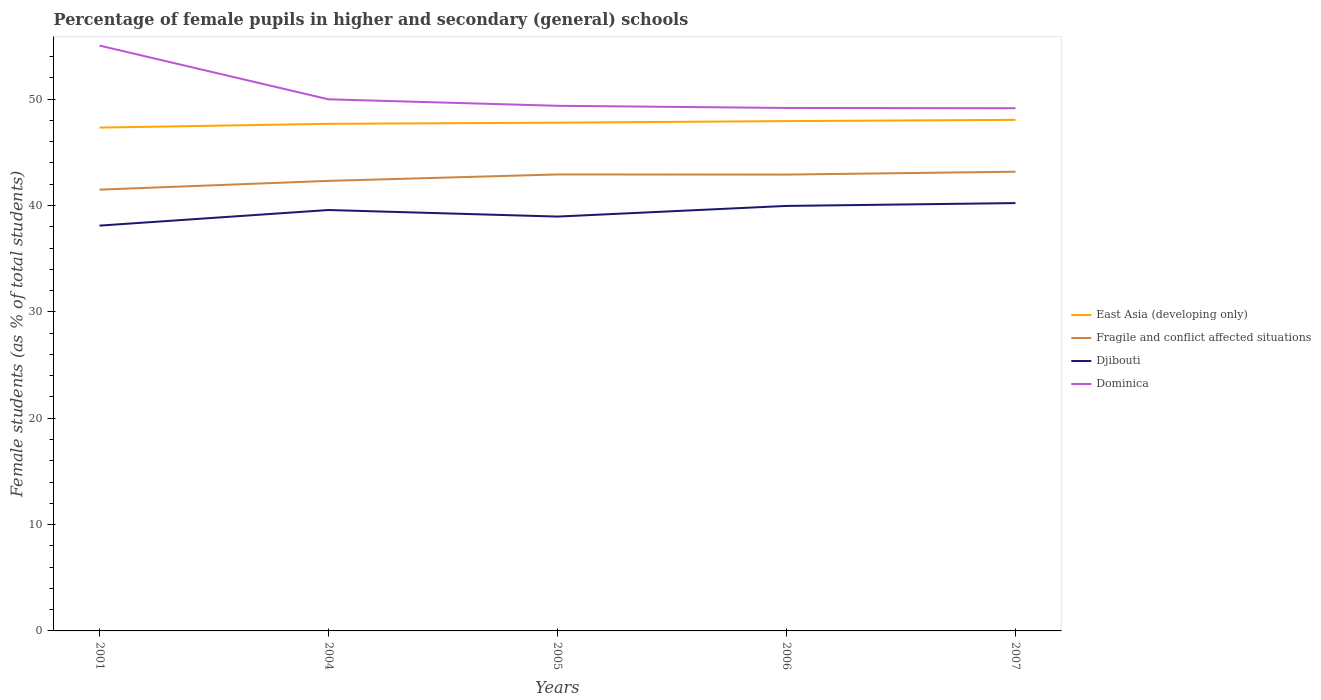Is the number of lines equal to the number of legend labels?
Your answer should be compact. Yes. Across all years, what is the maximum percentage of female pupils in higher and secondary schools in Fragile and conflict affected situations?
Give a very brief answer. 41.49. In which year was the percentage of female pupils in higher and secondary schools in Dominica maximum?
Ensure brevity in your answer.  2007. What is the total percentage of female pupils in higher and secondary schools in East Asia (developing only) in the graph?
Give a very brief answer. -0.61. What is the difference between the highest and the second highest percentage of female pupils in higher and secondary schools in Fragile and conflict affected situations?
Ensure brevity in your answer.  1.69. What is the difference between the highest and the lowest percentage of female pupils in higher and secondary schools in Djibouti?
Your response must be concise. 3. Is the percentage of female pupils in higher and secondary schools in Fragile and conflict affected situations strictly greater than the percentage of female pupils in higher and secondary schools in Djibouti over the years?
Keep it short and to the point. No. How many lines are there?
Keep it short and to the point. 4. Does the graph contain any zero values?
Provide a succinct answer. No. Does the graph contain grids?
Give a very brief answer. No. Where does the legend appear in the graph?
Offer a very short reply. Center right. How many legend labels are there?
Give a very brief answer. 4. What is the title of the graph?
Provide a succinct answer. Percentage of female pupils in higher and secondary (general) schools. What is the label or title of the Y-axis?
Offer a terse response. Female students (as % of total students). What is the Female students (as % of total students) of East Asia (developing only) in 2001?
Offer a very short reply. 47.33. What is the Female students (as % of total students) in Fragile and conflict affected situations in 2001?
Provide a succinct answer. 41.49. What is the Female students (as % of total students) of Djibouti in 2001?
Offer a very short reply. 38.11. What is the Female students (as % of total students) of Dominica in 2001?
Your answer should be compact. 55.04. What is the Female students (as % of total students) of East Asia (developing only) in 2004?
Provide a succinct answer. 47.68. What is the Female students (as % of total students) in Fragile and conflict affected situations in 2004?
Give a very brief answer. 42.32. What is the Female students (as % of total students) in Djibouti in 2004?
Provide a succinct answer. 39.58. What is the Female students (as % of total students) of Dominica in 2004?
Your answer should be very brief. 49.99. What is the Female students (as % of total students) of East Asia (developing only) in 2005?
Give a very brief answer. 47.79. What is the Female students (as % of total students) in Fragile and conflict affected situations in 2005?
Your answer should be very brief. 42.92. What is the Female students (as % of total students) of Djibouti in 2005?
Give a very brief answer. 38.96. What is the Female students (as % of total students) of Dominica in 2005?
Your response must be concise. 49.38. What is the Female students (as % of total students) of East Asia (developing only) in 2006?
Provide a short and direct response. 47.94. What is the Female students (as % of total students) in Fragile and conflict affected situations in 2006?
Make the answer very short. 42.91. What is the Female students (as % of total students) in Djibouti in 2006?
Provide a short and direct response. 39.96. What is the Female students (as % of total students) in Dominica in 2006?
Provide a succinct answer. 49.17. What is the Female students (as % of total students) of East Asia (developing only) in 2007?
Offer a terse response. 48.05. What is the Female students (as % of total students) of Fragile and conflict affected situations in 2007?
Keep it short and to the point. 43.18. What is the Female students (as % of total students) of Djibouti in 2007?
Your answer should be very brief. 40.23. What is the Female students (as % of total students) of Dominica in 2007?
Provide a succinct answer. 49.15. Across all years, what is the maximum Female students (as % of total students) in East Asia (developing only)?
Make the answer very short. 48.05. Across all years, what is the maximum Female students (as % of total students) of Fragile and conflict affected situations?
Your answer should be compact. 43.18. Across all years, what is the maximum Female students (as % of total students) in Djibouti?
Provide a succinct answer. 40.23. Across all years, what is the maximum Female students (as % of total students) of Dominica?
Keep it short and to the point. 55.04. Across all years, what is the minimum Female students (as % of total students) in East Asia (developing only)?
Ensure brevity in your answer.  47.33. Across all years, what is the minimum Female students (as % of total students) in Fragile and conflict affected situations?
Keep it short and to the point. 41.49. Across all years, what is the minimum Female students (as % of total students) in Djibouti?
Provide a short and direct response. 38.11. Across all years, what is the minimum Female students (as % of total students) in Dominica?
Provide a short and direct response. 49.15. What is the total Female students (as % of total students) in East Asia (developing only) in the graph?
Your answer should be very brief. 238.79. What is the total Female students (as % of total students) in Fragile and conflict affected situations in the graph?
Provide a short and direct response. 212.82. What is the total Female students (as % of total students) of Djibouti in the graph?
Give a very brief answer. 196.84. What is the total Female students (as % of total students) in Dominica in the graph?
Provide a succinct answer. 252.72. What is the difference between the Female students (as % of total students) in East Asia (developing only) in 2001 and that in 2004?
Your answer should be compact. -0.36. What is the difference between the Female students (as % of total students) of Fragile and conflict affected situations in 2001 and that in 2004?
Offer a terse response. -0.82. What is the difference between the Female students (as % of total students) in Djibouti in 2001 and that in 2004?
Provide a short and direct response. -1.47. What is the difference between the Female students (as % of total students) in Dominica in 2001 and that in 2004?
Your answer should be compact. 5.05. What is the difference between the Female students (as % of total students) in East Asia (developing only) in 2001 and that in 2005?
Provide a succinct answer. -0.47. What is the difference between the Female students (as % of total students) in Fragile and conflict affected situations in 2001 and that in 2005?
Give a very brief answer. -1.43. What is the difference between the Female students (as % of total students) of Djibouti in 2001 and that in 2005?
Your answer should be compact. -0.85. What is the difference between the Female students (as % of total students) of Dominica in 2001 and that in 2005?
Keep it short and to the point. 5.66. What is the difference between the Female students (as % of total students) in East Asia (developing only) in 2001 and that in 2006?
Offer a very short reply. -0.61. What is the difference between the Female students (as % of total students) of Fragile and conflict affected situations in 2001 and that in 2006?
Your answer should be very brief. -1.42. What is the difference between the Female students (as % of total students) in Djibouti in 2001 and that in 2006?
Keep it short and to the point. -1.85. What is the difference between the Female students (as % of total students) in Dominica in 2001 and that in 2006?
Offer a very short reply. 5.86. What is the difference between the Female students (as % of total students) in East Asia (developing only) in 2001 and that in 2007?
Keep it short and to the point. -0.73. What is the difference between the Female students (as % of total students) of Fragile and conflict affected situations in 2001 and that in 2007?
Provide a short and direct response. -1.69. What is the difference between the Female students (as % of total students) of Djibouti in 2001 and that in 2007?
Your answer should be compact. -2.12. What is the difference between the Female students (as % of total students) of Dominica in 2001 and that in 2007?
Give a very brief answer. 5.89. What is the difference between the Female students (as % of total students) in East Asia (developing only) in 2004 and that in 2005?
Provide a short and direct response. -0.11. What is the difference between the Female students (as % of total students) in Fragile and conflict affected situations in 2004 and that in 2005?
Offer a very short reply. -0.6. What is the difference between the Female students (as % of total students) in Djibouti in 2004 and that in 2005?
Your answer should be compact. 0.62. What is the difference between the Female students (as % of total students) in Dominica in 2004 and that in 2005?
Make the answer very short. 0.61. What is the difference between the Female students (as % of total students) of East Asia (developing only) in 2004 and that in 2006?
Offer a very short reply. -0.26. What is the difference between the Female students (as % of total students) in Fragile and conflict affected situations in 2004 and that in 2006?
Your response must be concise. -0.59. What is the difference between the Female students (as % of total students) of Djibouti in 2004 and that in 2006?
Give a very brief answer. -0.38. What is the difference between the Female students (as % of total students) of Dominica in 2004 and that in 2006?
Keep it short and to the point. 0.81. What is the difference between the Female students (as % of total students) in East Asia (developing only) in 2004 and that in 2007?
Make the answer very short. -0.37. What is the difference between the Female students (as % of total students) in Fragile and conflict affected situations in 2004 and that in 2007?
Provide a short and direct response. -0.86. What is the difference between the Female students (as % of total students) in Djibouti in 2004 and that in 2007?
Your answer should be compact. -0.65. What is the difference between the Female students (as % of total students) in Dominica in 2004 and that in 2007?
Your response must be concise. 0.84. What is the difference between the Female students (as % of total students) in East Asia (developing only) in 2005 and that in 2006?
Give a very brief answer. -0.15. What is the difference between the Female students (as % of total students) of Fragile and conflict affected situations in 2005 and that in 2006?
Give a very brief answer. 0.01. What is the difference between the Female students (as % of total students) of Djibouti in 2005 and that in 2006?
Offer a terse response. -1. What is the difference between the Female students (as % of total students) in Dominica in 2005 and that in 2006?
Your answer should be compact. 0.2. What is the difference between the Female students (as % of total students) in East Asia (developing only) in 2005 and that in 2007?
Provide a short and direct response. -0.26. What is the difference between the Female students (as % of total students) in Fragile and conflict affected situations in 2005 and that in 2007?
Provide a succinct answer. -0.26. What is the difference between the Female students (as % of total students) in Djibouti in 2005 and that in 2007?
Provide a short and direct response. -1.27. What is the difference between the Female students (as % of total students) of Dominica in 2005 and that in 2007?
Make the answer very short. 0.23. What is the difference between the Female students (as % of total students) of East Asia (developing only) in 2006 and that in 2007?
Provide a short and direct response. -0.12. What is the difference between the Female students (as % of total students) in Fragile and conflict affected situations in 2006 and that in 2007?
Provide a short and direct response. -0.27. What is the difference between the Female students (as % of total students) of Djibouti in 2006 and that in 2007?
Your response must be concise. -0.27. What is the difference between the Female students (as % of total students) of Dominica in 2006 and that in 2007?
Your response must be concise. 0.03. What is the difference between the Female students (as % of total students) of East Asia (developing only) in 2001 and the Female students (as % of total students) of Fragile and conflict affected situations in 2004?
Offer a very short reply. 5.01. What is the difference between the Female students (as % of total students) in East Asia (developing only) in 2001 and the Female students (as % of total students) in Djibouti in 2004?
Offer a terse response. 7.75. What is the difference between the Female students (as % of total students) of East Asia (developing only) in 2001 and the Female students (as % of total students) of Dominica in 2004?
Your response must be concise. -2.66. What is the difference between the Female students (as % of total students) of Fragile and conflict affected situations in 2001 and the Female students (as % of total students) of Djibouti in 2004?
Your answer should be compact. 1.91. What is the difference between the Female students (as % of total students) of Fragile and conflict affected situations in 2001 and the Female students (as % of total students) of Dominica in 2004?
Your answer should be very brief. -8.49. What is the difference between the Female students (as % of total students) in Djibouti in 2001 and the Female students (as % of total students) in Dominica in 2004?
Provide a succinct answer. -11.88. What is the difference between the Female students (as % of total students) of East Asia (developing only) in 2001 and the Female students (as % of total students) of Fragile and conflict affected situations in 2005?
Offer a terse response. 4.4. What is the difference between the Female students (as % of total students) in East Asia (developing only) in 2001 and the Female students (as % of total students) in Djibouti in 2005?
Your response must be concise. 8.37. What is the difference between the Female students (as % of total students) of East Asia (developing only) in 2001 and the Female students (as % of total students) of Dominica in 2005?
Offer a very short reply. -2.05. What is the difference between the Female students (as % of total students) of Fragile and conflict affected situations in 2001 and the Female students (as % of total students) of Djibouti in 2005?
Provide a short and direct response. 2.53. What is the difference between the Female students (as % of total students) of Fragile and conflict affected situations in 2001 and the Female students (as % of total students) of Dominica in 2005?
Your answer should be very brief. -7.88. What is the difference between the Female students (as % of total students) of Djibouti in 2001 and the Female students (as % of total students) of Dominica in 2005?
Your response must be concise. -11.27. What is the difference between the Female students (as % of total students) in East Asia (developing only) in 2001 and the Female students (as % of total students) in Fragile and conflict affected situations in 2006?
Provide a short and direct response. 4.42. What is the difference between the Female students (as % of total students) in East Asia (developing only) in 2001 and the Female students (as % of total students) in Djibouti in 2006?
Your response must be concise. 7.36. What is the difference between the Female students (as % of total students) of East Asia (developing only) in 2001 and the Female students (as % of total students) of Dominica in 2006?
Your answer should be very brief. -1.85. What is the difference between the Female students (as % of total students) of Fragile and conflict affected situations in 2001 and the Female students (as % of total students) of Djibouti in 2006?
Keep it short and to the point. 1.53. What is the difference between the Female students (as % of total students) of Fragile and conflict affected situations in 2001 and the Female students (as % of total students) of Dominica in 2006?
Your answer should be compact. -7.68. What is the difference between the Female students (as % of total students) in Djibouti in 2001 and the Female students (as % of total students) in Dominica in 2006?
Your response must be concise. -11.06. What is the difference between the Female students (as % of total students) in East Asia (developing only) in 2001 and the Female students (as % of total students) in Fragile and conflict affected situations in 2007?
Your answer should be very brief. 4.15. What is the difference between the Female students (as % of total students) of East Asia (developing only) in 2001 and the Female students (as % of total students) of Djibouti in 2007?
Make the answer very short. 7.1. What is the difference between the Female students (as % of total students) in East Asia (developing only) in 2001 and the Female students (as % of total students) in Dominica in 2007?
Keep it short and to the point. -1.82. What is the difference between the Female students (as % of total students) in Fragile and conflict affected situations in 2001 and the Female students (as % of total students) in Djibouti in 2007?
Your answer should be very brief. 1.26. What is the difference between the Female students (as % of total students) of Fragile and conflict affected situations in 2001 and the Female students (as % of total students) of Dominica in 2007?
Offer a very short reply. -7.66. What is the difference between the Female students (as % of total students) of Djibouti in 2001 and the Female students (as % of total students) of Dominica in 2007?
Make the answer very short. -11.04. What is the difference between the Female students (as % of total students) in East Asia (developing only) in 2004 and the Female students (as % of total students) in Fragile and conflict affected situations in 2005?
Make the answer very short. 4.76. What is the difference between the Female students (as % of total students) of East Asia (developing only) in 2004 and the Female students (as % of total students) of Djibouti in 2005?
Give a very brief answer. 8.72. What is the difference between the Female students (as % of total students) of East Asia (developing only) in 2004 and the Female students (as % of total students) of Dominica in 2005?
Your answer should be compact. -1.69. What is the difference between the Female students (as % of total students) of Fragile and conflict affected situations in 2004 and the Female students (as % of total students) of Djibouti in 2005?
Offer a terse response. 3.36. What is the difference between the Female students (as % of total students) of Fragile and conflict affected situations in 2004 and the Female students (as % of total students) of Dominica in 2005?
Make the answer very short. -7.06. What is the difference between the Female students (as % of total students) in Djibouti in 2004 and the Female students (as % of total students) in Dominica in 2005?
Your response must be concise. -9.8. What is the difference between the Female students (as % of total students) in East Asia (developing only) in 2004 and the Female students (as % of total students) in Fragile and conflict affected situations in 2006?
Your response must be concise. 4.77. What is the difference between the Female students (as % of total students) of East Asia (developing only) in 2004 and the Female students (as % of total students) of Djibouti in 2006?
Your answer should be compact. 7.72. What is the difference between the Female students (as % of total students) of East Asia (developing only) in 2004 and the Female students (as % of total students) of Dominica in 2006?
Your answer should be compact. -1.49. What is the difference between the Female students (as % of total students) of Fragile and conflict affected situations in 2004 and the Female students (as % of total students) of Djibouti in 2006?
Ensure brevity in your answer.  2.35. What is the difference between the Female students (as % of total students) in Fragile and conflict affected situations in 2004 and the Female students (as % of total students) in Dominica in 2006?
Provide a succinct answer. -6.86. What is the difference between the Female students (as % of total students) of Djibouti in 2004 and the Female students (as % of total students) of Dominica in 2006?
Provide a succinct answer. -9.6. What is the difference between the Female students (as % of total students) in East Asia (developing only) in 2004 and the Female students (as % of total students) in Fragile and conflict affected situations in 2007?
Give a very brief answer. 4.5. What is the difference between the Female students (as % of total students) of East Asia (developing only) in 2004 and the Female students (as % of total students) of Djibouti in 2007?
Your answer should be very brief. 7.45. What is the difference between the Female students (as % of total students) in East Asia (developing only) in 2004 and the Female students (as % of total students) in Dominica in 2007?
Ensure brevity in your answer.  -1.46. What is the difference between the Female students (as % of total students) in Fragile and conflict affected situations in 2004 and the Female students (as % of total students) in Djibouti in 2007?
Offer a very short reply. 2.09. What is the difference between the Female students (as % of total students) in Fragile and conflict affected situations in 2004 and the Female students (as % of total students) in Dominica in 2007?
Offer a terse response. -6.83. What is the difference between the Female students (as % of total students) in Djibouti in 2004 and the Female students (as % of total students) in Dominica in 2007?
Provide a succinct answer. -9.57. What is the difference between the Female students (as % of total students) of East Asia (developing only) in 2005 and the Female students (as % of total students) of Fragile and conflict affected situations in 2006?
Keep it short and to the point. 4.88. What is the difference between the Female students (as % of total students) in East Asia (developing only) in 2005 and the Female students (as % of total students) in Djibouti in 2006?
Your answer should be very brief. 7.83. What is the difference between the Female students (as % of total students) in East Asia (developing only) in 2005 and the Female students (as % of total students) in Dominica in 2006?
Give a very brief answer. -1.38. What is the difference between the Female students (as % of total students) in Fragile and conflict affected situations in 2005 and the Female students (as % of total students) in Djibouti in 2006?
Provide a short and direct response. 2.96. What is the difference between the Female students (as % of total students) in Fragile and conflict affected situations in 2005 and the Female students (as % of total students) in Dominica in 2006?
Give a very brief answer. -6.25. What is the difference between the Female students (as % of total students) of Djibouti in 2005 and the Female students (as % of total students) of Dominica in 2006?
Offer a very short reply. -10.21. What is the difference between the Female students (as % of total students) in East Asia (developing only) in 2005 and the Female students (as % of total students) in Fragile and conflict affected situations in 2007?
Make the answer very short. 4.61. What is the difference between the Female students (as % of total students) in East Asia (developing only) in 2005 and the Female students (as % of total students) in Djibouti in 2007?
Provide a succinct answer. 7.56. What is the difference between the Female students (as % of total students) in East Asia (developing only) in 2005 and the Female students (as % of total students) in Dominica in 2007?
Your answer should be compact. -1.36. What is the difference between the Female students (as % of total students) in Fragile and conflict affected situations in 2005 and the Female students (as % of total students) in Djibouti in 2007?
Provide a succinct answer. 2.69. What is the difference between the Female students (as % of total students) of Fragile and conflict affected situations in 2005 and the Female students (as % of total students) of Dominica in 2007?
Your answer should be very brief. -6.23. What is the difference between the Female students (as % of total students) of Djibouti in 2005 and the Female students (as % of total students) of Dominica in 2007?
Your answer should be compact. -10.19. What is the difference between the Female students (as % of total students) in East Asia (developing only) in 2006 and the Female students (as % of total students) in Fragile and conflict affected situations in 2007?
Your answer should be compact. 4.76. What is the difference between the Female students (as % of total students) of East Asia (developing only) in 2006 and the Female students (as % of total students) of Djibouti in 2007?
Give a very brief answer. 7.71. What is the difference between the Female students (as % of total students) of East Asia (developing only) in 2006 and the Female students (as % of total students) of Dominica in 2007?
Give a very brief answer. -1.21. What is the difference between the Female students (as % of total students) in Fragile and conflict affected situations in 2006 and the Female students (as % of total students) in Djibouti in 2007?
Give a very brief answer. 2.68. What is the difference between the Female students (as % of total students) in Fragile and conflict affected situations in 2006 and the Female students (as % of total students) in Dominica in 2007?
Offer a terse response. -6.24. What is the difference between the Female students (as % of total students) of Djibouti in 2006 and the Female students (as % of total students) of Dominica in 2007?
Provide a succinct answer. -9.18. What is the average Female students (as % of total students) of East Asia (developing only) per year?
Provide a short and direct response. 47.76. What is the average Female students (as % of total students) in Fragile and conflict affected situations per year?
Keep it short and to the point. 42.56. What is the average Female students (as % of total students) in Djibouti per year?
Provide a short and direct response. 39.37. What is the average Female students (as % of total students) of Dominica per year?
Provide a short and direct response. 50.54. In the year 2001, what is the difference between the Female students (as % of total students) of East Asia (developing only) and Female students (as % of total students) of Fragile and conflict affected situations?
Ensure brevity in your answer.  5.83. In the year 2001, what is the difference between the Female students (as % of total students) in East Asia (developing only) and Female students (as % of total students) in Djibouti?
Provide a succinct answer. 9.22. In the year 2001, what is the difference between the Female students (as % of total students) of East Asia (developing only) and Female students (as % of total students) of Dominica?
Offer a very short reply. -7.71. In the year 2001, what is the difference between the Female students (as % of total students) of Fragile and conflict affected situations and Female students (as % of total students) of Djibouti?
Your answer should be compact. 3.38. In the year 2001, what is the difference between the Female students (as % of total students) of Fragile and conflict affected situations and Female students (as % of total students) of Dominica?
Give a very brief answer. -13.55. In the year 2001, what is the difference between the Female students (as % of total students) of Djibouti and Female students (as % of total students) of Dominica?
Offer a very short reply. -16.93. In the year 2004, what is the difference between the Female students (as % of total students) in East Asia (developing only) and Female students (as % of total students) in Fragile and conflict affected situations?
Provide a succinct answer. 5.37. In the year 2004, what is the difference between the Female students (as % of total students) in East Asia (developing only) and Female students (as % of total students) in Djibouti?
Ensure brevity in your answer.  8.1. In the year 2004, what is the difference between the Female students (as % of total students) in East Asia (developing only) and Female students (as % of total students) in Dominica?
Offer a terse response. -2.3. In the year 2004, what is the difference between the Female students (as % of total students) of Fragile and conflict affected situations and Female students (as % of total students) of Djibouti?
Make the answer very short. 2.74. In the year 2004, what is the difference between the Female students (as % of total students) in Fragile and conflict affected situations and Female students (as % of total students) in Dominica?
Your response must be concise. -7.67. In the year 2004, what is the difference between the Female students (as % of total students) in Djibouti and Female students (as % of total students) in Dominica?
Offer a very short reply. -10.41. In the year 2005, what is the difference between the Female students (as % of total students) of East Asia (developing only) and Female students (as % of total students) of Fragile and conflict affected situations?
Your response must be concise. 4.87. In the year 2005, what is the difference between the Female students (as % of total students) of East Asia (developing only) and Female students (as % of total students) of Djibouti?
Provide a short and direct response. 8.83. In the year 2005, what is the difference between the Female students (as % of total students) of East Asia (developing only) and Female students (as % of total students) of Dominica?
Offer a very short reply. -1.59. In the year 2005, what is the difference between the Female students (as % of total students) of Fragile and conflict affected situations and Female students (as % of total students) of Djibouti?
Give a very brief answer. 3.96. In the year 2005, what is the difference between the Female students (as % of total students) of Fragile and conflict affected situations and Female students (as % of total students) of Dominica?
Offer a very short reply. -6.46. In the year 2005, what is the difference between the Female students (as % of total students) of Djibouti and Female students (as % of total students) of Dominica?
Offer a terse response. -10.42. In the year 2006, what is the difference between the Female students (as % of total students) in East Asia (developing only) and Female students (as % of total students) in Fragile and conflict affected situations?
Ensure brevity in your answer.  5.03. In the year 2006, what is the difference between the Female students (as % of total students) of East Asia (developing only) and Female students (as % of total students) of Djibouti?
Your answer should be very brief. 7.98. In the year 2006, what is the difference between the Female students (as % of total students) of East Asia (developing only) and Female students (as % of total students) of Dominica?
Make the answer very short. -1.24. In the year 2006, what is the difference between the Female students (as % of total students) of Fragile and conflict affected situations and Female students (as % of total students) of Djibouti?
Keep it short and to the point. 2.95. In the year 2006, what is the difference between the Female students (as % of total students) in Fragile and conflict affected situations and Female students (as % of total students) in Dominica?
Ensure brevity in your answer.  -6.26. In the year 2006, what is the difference between the Female students (as % of total students) in Djibouti and Female students (as % of total students) in Dominica?
Your response must be concise. -9.21. In the year 2007, what is the difference between the Female students (as % of total students) in East Asia (developing only) and Female students (as % of total students) in Fragile and conflict affected situations?
Provide a succinct answer. 4.88. In the year 2007, what is the difference between the Female students (as % of total students) in East Asia (developing only) and Female students (as % of total students) in Djibouti?
Your answer should be very brief. 7.83. In the year 2007, what is the difference between the Female students (as % of total students) in East Asia (developing only) and Female students (as % of total students) in Dominica?
Keep it short and to the point. -1.09. In the year 2007, what is the difference between the Female students (as % of total students) of Fragile and conflict affected situations and Female students (as % of total students) of Djibouti?
Provide a succinct answer. 2.95. In the year 2007, what is the difference between the Female students (as % of total students) in Fragile and conflict affected situations and Female students (as % of total students) in Dominica?
Provide a succinct answer. -5.97. In the year 2007, what is the difference between the Female students (as % of total students) of Djibouti and Female students (as % of total students) of Dominica?
Your response must be concise. -8.92. What is the ratio of the Female students (as % of total students) in Fragile and conflict affected situations in 2001 to that in 2004?
Ensure brevity in your answer.  0.98. What is the ratio of the Female students (as % of total students) in Djibouti in 2001 to that in 2004?
Your answer should be compact. 0.96. What is the ratio of the Female students (as % of total students) of Dominica in 2001 to that in 2004?
Ensure brevity in your answer.  1.1. What is the ratio of the Female students (as % of total students) of East Asia (developing only) in 2001 to that in 2005?
Your answer should be very brief. 0.99. What is the ratio of the Female students (as % of total students) of Fragile and conflict affected situations in 2001 to that in 2005?
Provide a succinct answer. 0.97. What is the ratio of the Female students (as % of total students) of Djibouti in 2001 to that in 2005?
Keep it short and to the point. 0.98. What is the ratio of the Female students (as % of total students) in Dominica in 2001 to that in 2005?
Give a very brief answer. 1.11. What is the ratio of the Female students (as % of total students) of East Asia (developing only) in 2001 to that in 2006?
Your answer should be compact. 0.99. What is the ratio of the Female students (as % of total students) of Fragile and conflict affected situations in 2001 to that in 2006?
Your answer should be compact. 0.97. What is the ratio of the Female students (as % of total students) of Djibouti in 2001 to that in 2006?
Keep it short and to the point. 0.95. What is the ratio of the Female students (as % of total students) of Dominica in 2001 to that in 2006?
Ensure brevity in your answer.  1.12. What is the ratio of the Female students (as % of total students) in Fragile and conflict affected situations in 2001 to that in 2007?
Your answer should be compact. 0.96. What is the ratio of the Female students (as % of total students) in Djibouti in 2001 to that in 2007?
Keep it short and to the point. 0.95. What is the ratio of the Female students (as % of total students) of Dominica in 2001 to that in 2007?
Make the answer very short. 1.12. What is the ratio of the Female students (as % of total students) of Fragile and conflict affected situations in 2004 to that in 2005?
Your answer should be very brief. 0.99. What is the ratio of the Female students (as % of total students) of Djibouti in 2004 to that in 2005?
Offer a very short reply. 1.02. What is the ratio of the Female students (as % of total students) in Dominica in 2004 to that in 2005?
Keep it short and to the point. 1.01. What is the ratio of the Female students (as % of total students) in Fragile and conflict affected situations in 2004 to that in 2006?
Keep it short and to the point. 0.99. What is the ratio of the Female students (as % of total students) in Djibouti in 2004 to that in 2006?
Your answer should be compact. 0.99. What is the ratio of the Female students (as % of total students) in Dominica in 2004 to that in 2006?
Offer a very short reply. 1.02. What is the ratio of the Female students (as % of total students) of East Asia (developing only) in 2004 to that in 2007?
Provide a short and direct response. 0.99. What is the ratio of the Female students (as % of total students) in Fragile and conflict affected situations in 2004 to that in 2007?
Offer a very short reply. 0.98. What is the ratio of the Female students (as % of total students) in Djibouti in 2004 to that in 2007?
Your response must be concise. 0.98. What is the ratio of the Female students (as % of total students) of Dominica in 2004 to that in 2007?
Your response must be concise. 1.02. What is the ratio of the Female students (as % of total students) of Djibouti in 2005 to that in 2006?
Your response must be concise. 0.97. What is the ratio of the Female students (as % of total students) in Dominica in 2005 to that in 2006?
Give a very brief answer. 1. What is the ratio of the Female students (as % of total students) of East Asia (developing only) in 2005 to that in 2007?
Keep it short and to the point. 0.99. What is the ratio of the Female students (as % of total students) in Fragile and conflict affected situations in 2005 to that in 2007?
Your answer should be compact. 0.99. What is the ratio of the Female students (as % of total students) of Djibouti in 2005 to that in 2007?
Your response must be concise. 0.97. What is the ratio of the Female students (as % of total students) in Dominica in 2005 to that in 2007?
Keep it short and to the point. 1. What is the ratio of the Female students (as % of total students) in East Asia (developing only) in 2006 to that in 2007?
Provide a short and direct response. 1. What is the ratio of the Female students (as % of total students) in Dominica in 2006 to that in 2007?
Provide a succinct answer. 1. What is the difference between the highest and the second highest Female students (as % of total students) in East Asia (developing only)?
Ensure brevity in your answer.  0.12. What is the difference between the highest and the second highest Female students (as % of total students) in Fragile and conflict affected situations?
Give a very brief answer. 0.26. What is the difference between the highest and the second highest Female students (as % of total students) in Djibouti?
Make the answer very short. 0.27. What is the difference between the highest and the second highest Female students (as % of total students) of Dominica?
Give a very brief answer. 5.05. What is the difference between the highest and the lowest Female students (as % of total students) of East Asia (developing only)?
Make the answer very short. 0.73. What is the difference between the highest and the lowest Female students (as % of total students) of Fragile and conflict affected situations?
Your answer should be very brief. 1.69. What is the difference between the highest and the lowest Female students (as % of total students) in Djibouti?
Your answer should be compact. 2.12. What is the difference between the highest and the lowest Female students (as % of total students) in Dominica?
Provide a succinct answer. 5.89. 